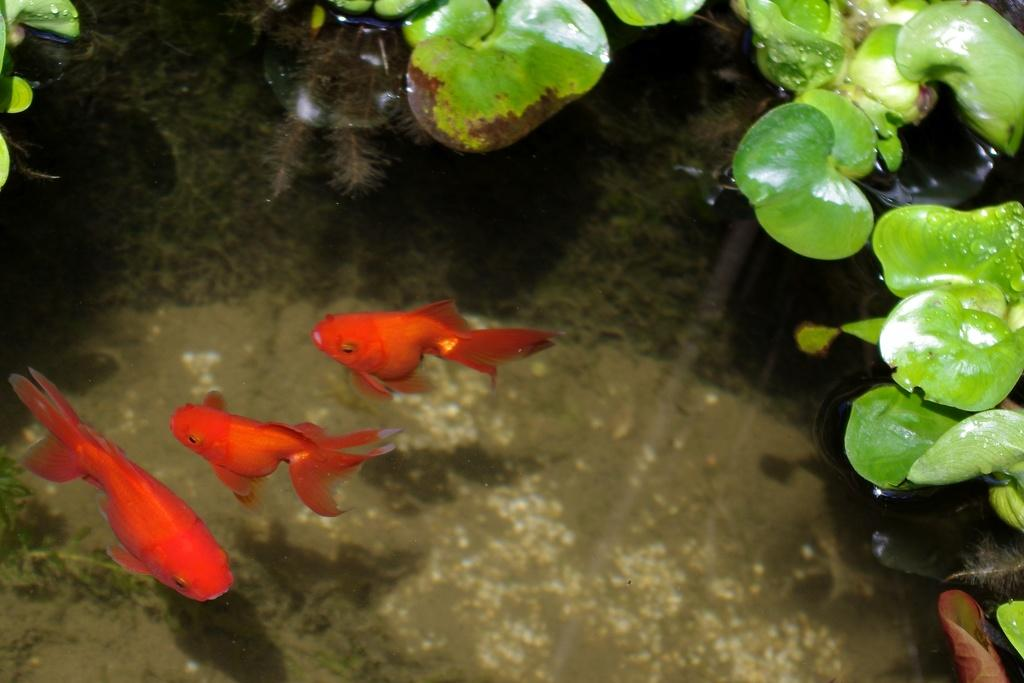What color are the fish in the water? The fish in the water are red. How many fish can be seen in the image? There are three fish in the image. What is visible on the top right of the image? There are green color leaves visible on the top right of the image. How many spiders are crawling on the tongue in the image? There are no spiders or tongues present in the image. What degree of difficulty is required to obtain the degree shown in the image? There is no degree present in the image. 